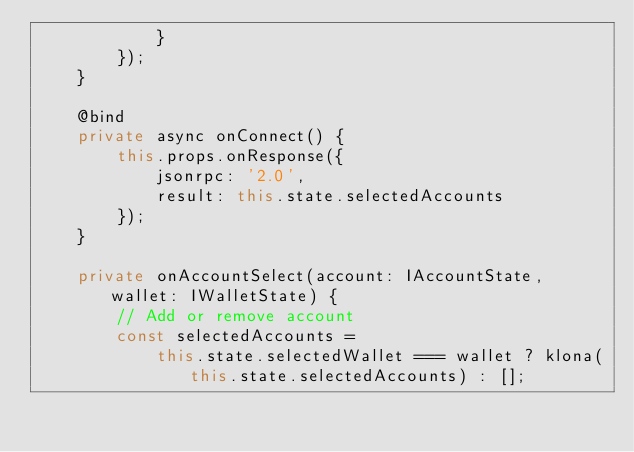<code> <loc_0><loc_0><loc_500><loc_500><_TypeScript_>            }
        });
    }

    @bind
    private async onConnect() {
        this.props.onResponse({
            jsonrpc: '2.0',
            result: this.state.selectedAccounts
        });
    }

    private onAccountSelect(account: IAccountState, wallet: IWalletState) {
        // Add or remove account
        const selectedAccounts =
            this.state.selectedWallet === wallet ? klona(this.state.selectedAccounts) : [];
</code> 